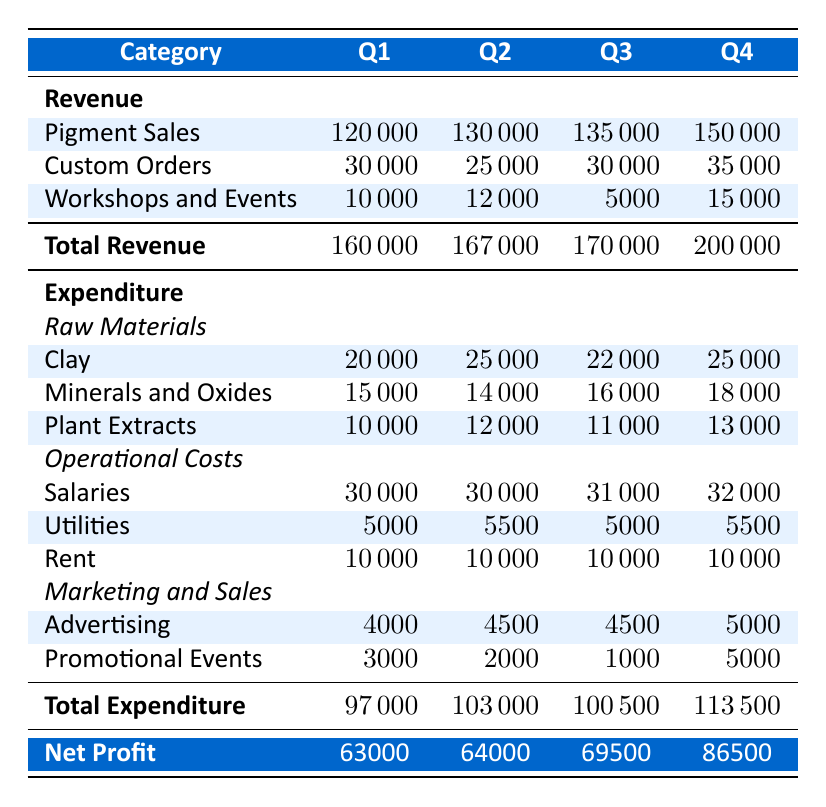What was the total revenue in Q3? To find the total revenue in Q3, we look at the Total Revenue row in the table and find the value corresponding to Q3, which is 170000.
Answer: 170000 Which quarter had the highest expenditure? By comparing the Total Expenditure row for all quarters, we see that Q4 has the highest value at 113500.
Answer: Q4 What is the net profit for Q2? The net profit for Q2 can be found directly in the Net Profit row under Q2, which is 64000.
Answer: 64000 What is the average revenue from Custom Orders across all quarters? We first sum the Custom Orders revenue for all quarters: 30000 + 25000 + 30000 + 35000 = 120000. Then we divide by 4 (the number of quarters), which gives us an average of 120000 / 4 = 30000.
Answer: 30000 Did the expenditure on Plant Extracts increase from Q1 to Q4? By checking the values in the Plant Extracts row, we notice that Q1 is 10000 and Q4 is 13000, confirming that the expenditure increased over this period.
Answer: Yes What was the total expenditure on Raw Materials in Q3? To find the total expenditure on Raw Materials in Q3, we sum the expenditures of Clay, Minerals and Oxides, and Plant Extracts: 22000 + 16000 + 11000 = 49000.
Answer: 49000 Which revenue category had the lowest value in Q1? In Q1, we compare the values from each revenue category: Pigment Sales (120000), Custom Orders (30000), and Workshops and Events (10000). The lowest value is from Workshops and Events at 10000.
Answer: Workshops and Events How much did expenditure on Advertising change from Q1 to Q4? We look at the Advertising expenditure for Q1 (4000) and for Q4 (5000). The change is calculated as 5000 - 4000 = 1000, indicating an increase of 1000.
Answer: Increased by 1000 What is the total net profit across all quarters? To find the total net profit, we sum the net profit values for all quarters: 63000 + 64000 + 69500 + 86500 = 283000.
Answer: 283000 